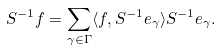Convert formula to latex. <formula><loc_0><loc_0><loc_500><loc_500>S ^ { - 1 } f = \sum _ { \gamma \in \Gamma } \langle f , S ^ { - 1 } e _ { \gamma } \rangle S ^ { - 1 } e _ { \gamma } .</formula> 